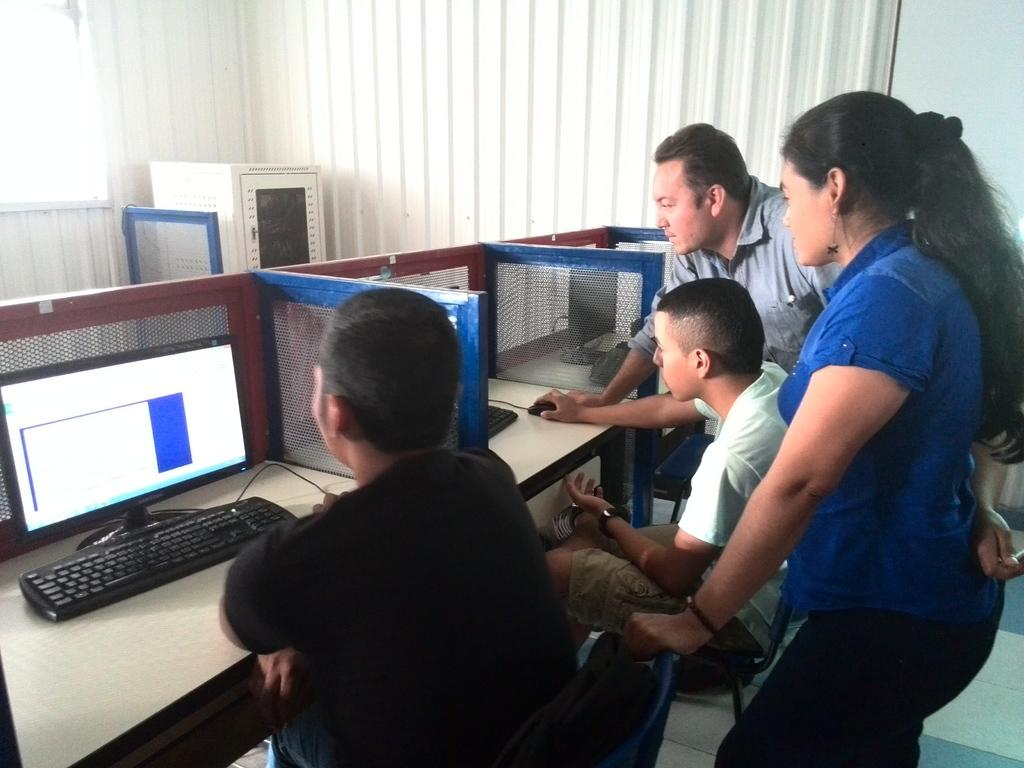How many people are in the image? There are four persons in the image. What is the man in the image doing? The man is sitting on a chair in the image. What is the man sitting in front of? The man is in front of a system. What can be seen in the background of the image? There are curtains in the background of the image. What type of dress is the man wearing in the image? The man is not wearing a dress in the image; he is wearing regular clothing. What event is taking place in the image? There is no specific event taking place in the image; it simply shows four people and a man sitting in front of a system. 